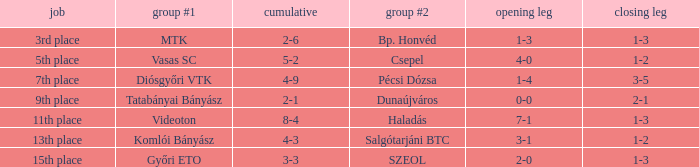What is the 2nd leg of the 4-9 agg.? 3-5. 